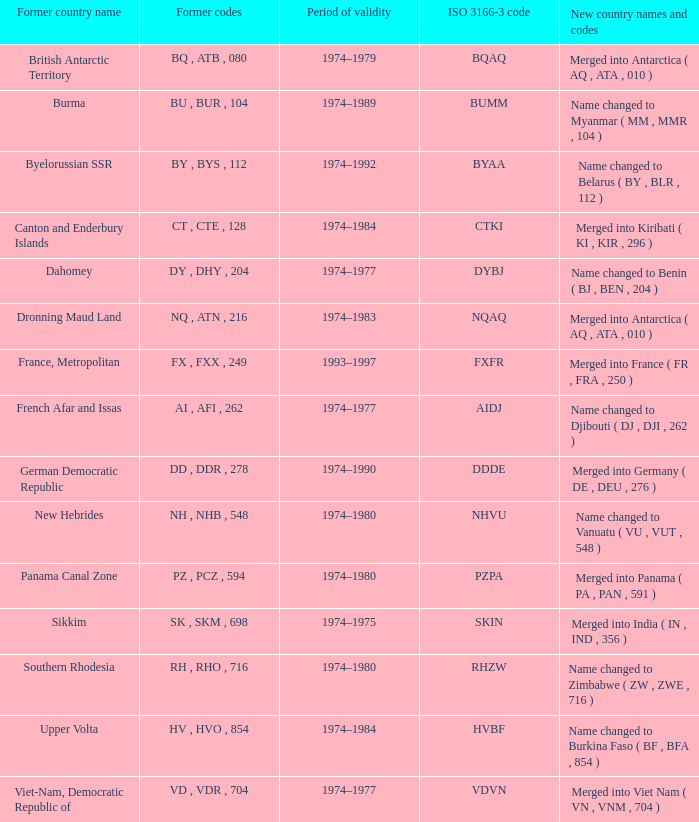Name the former codes for  merged into panama ( pa , pan , 591 ) PZ , PCZ , 594. 